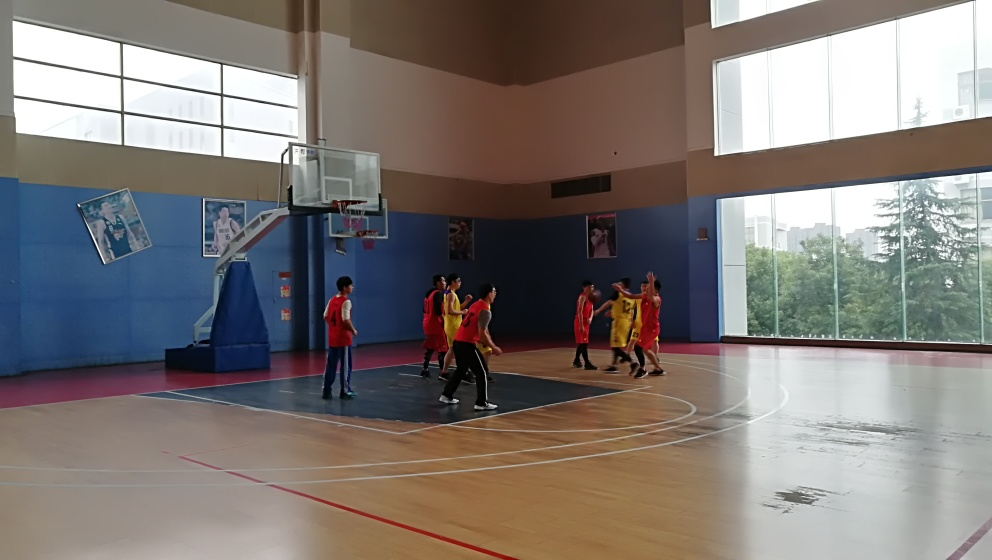What is happening in this photo? The photo captures a moment during a basketball game inside an indoor court. Players in red and yellow jerseys are in various stances of play, suggesting a dynamic and competitive atmosphere. 